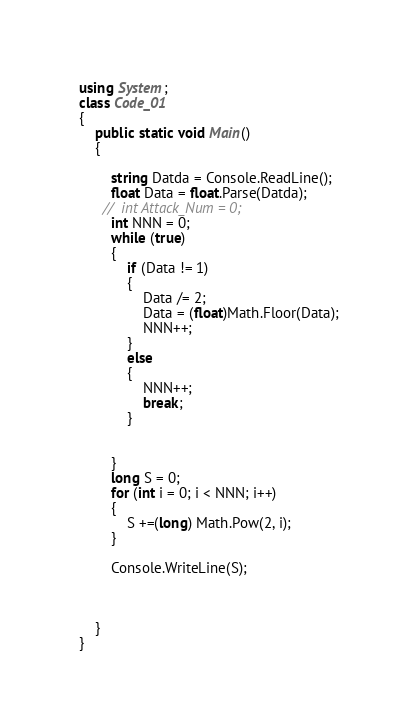Convert code to text. <code><loc_0><loc_0><loc_500><loc_500><_C#_>using System;
class Code_01
{
    public static void Main()
    {

        string Datda = Console.ReadLine();
        float Data = float.Parse(Datda);
      //  int Attack_Num = 0;
        int NNN = 0;
        while (true)
        {
            if (Data != 1)
            {
                Data /= 2;
                Data = (float)Math.Floor(Data);
                NNN++;
            }
            else
            {
                NNN++;
                break;
            }
          
            
        }
        long S = 0;
        for (int i = 0; i < NNN; i++)
        {
            S +=(long) Math.Pow(2, i);
        }
      
        Console.WriteLine(S);
      


    }
}
</code> 